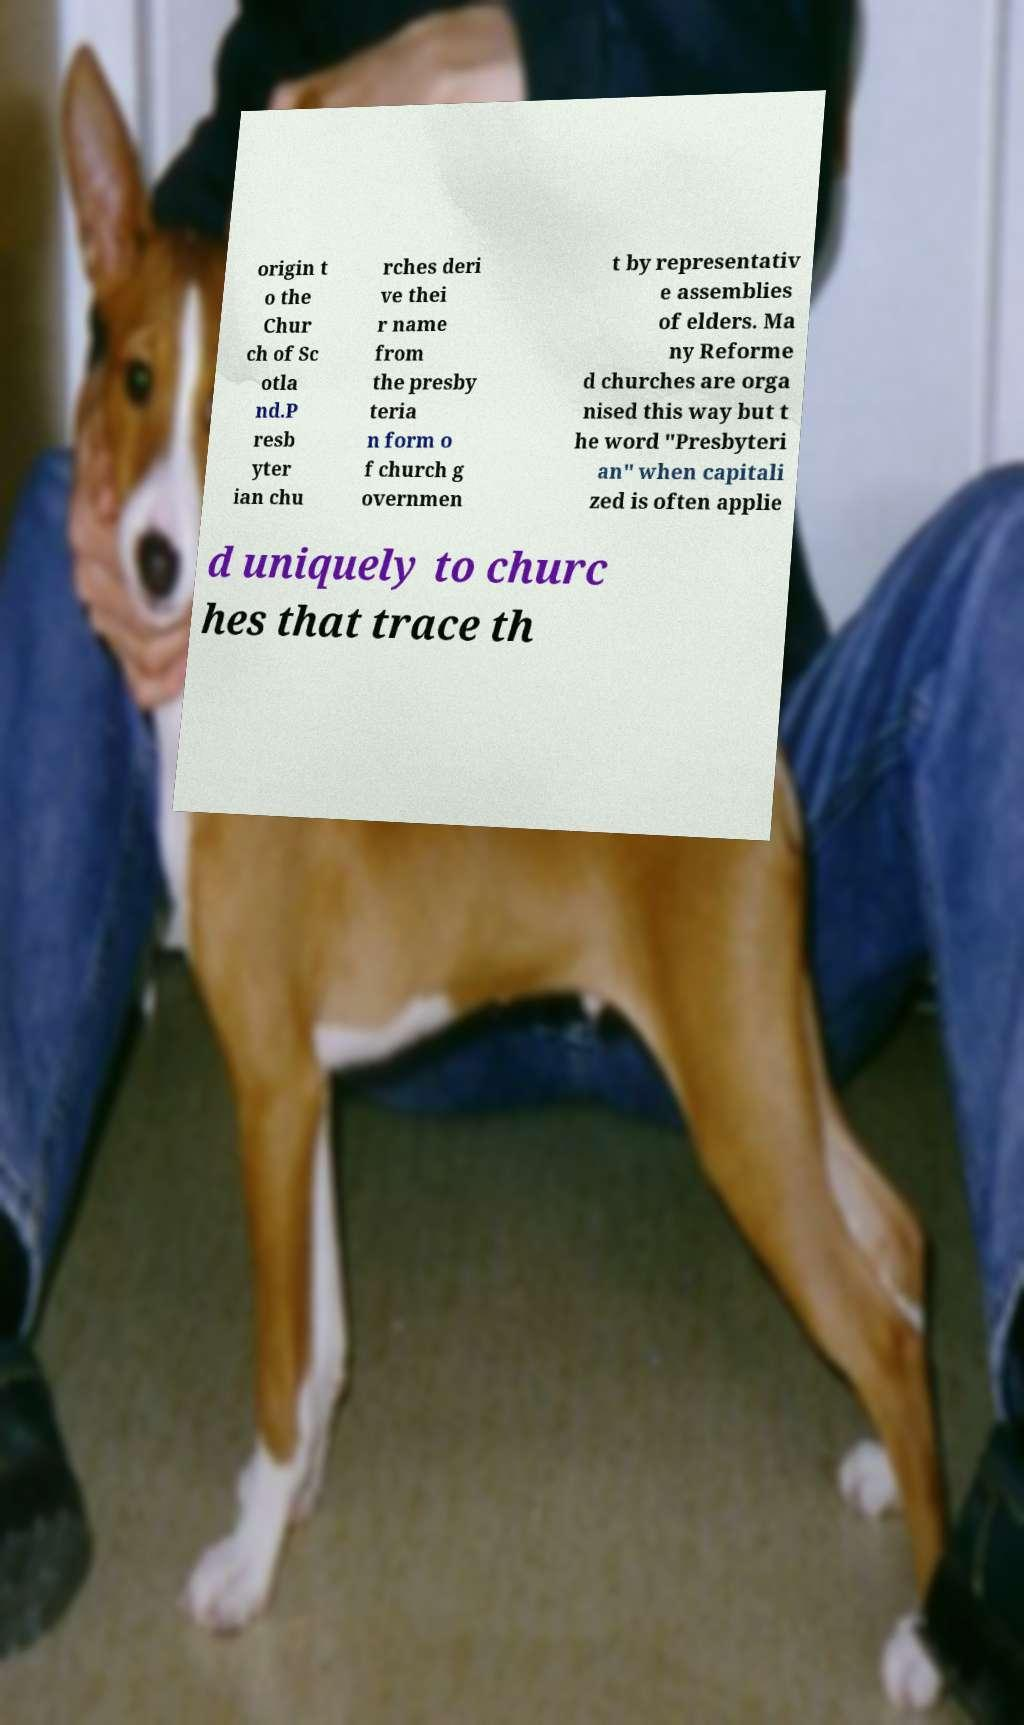Could you extract and type out the text from this image? origin t o the Chur ch of Sc otla nd.P resb yter ian chu rches deri ve thei r name from the presby teria n form o f church g overnmen t by representativ e assemblies of elders. Ma ny Reforme d churches are orga nised this way but t he word "Presbyteri an" when capitali zed is often applie d uniquely to churc hes that trace th 